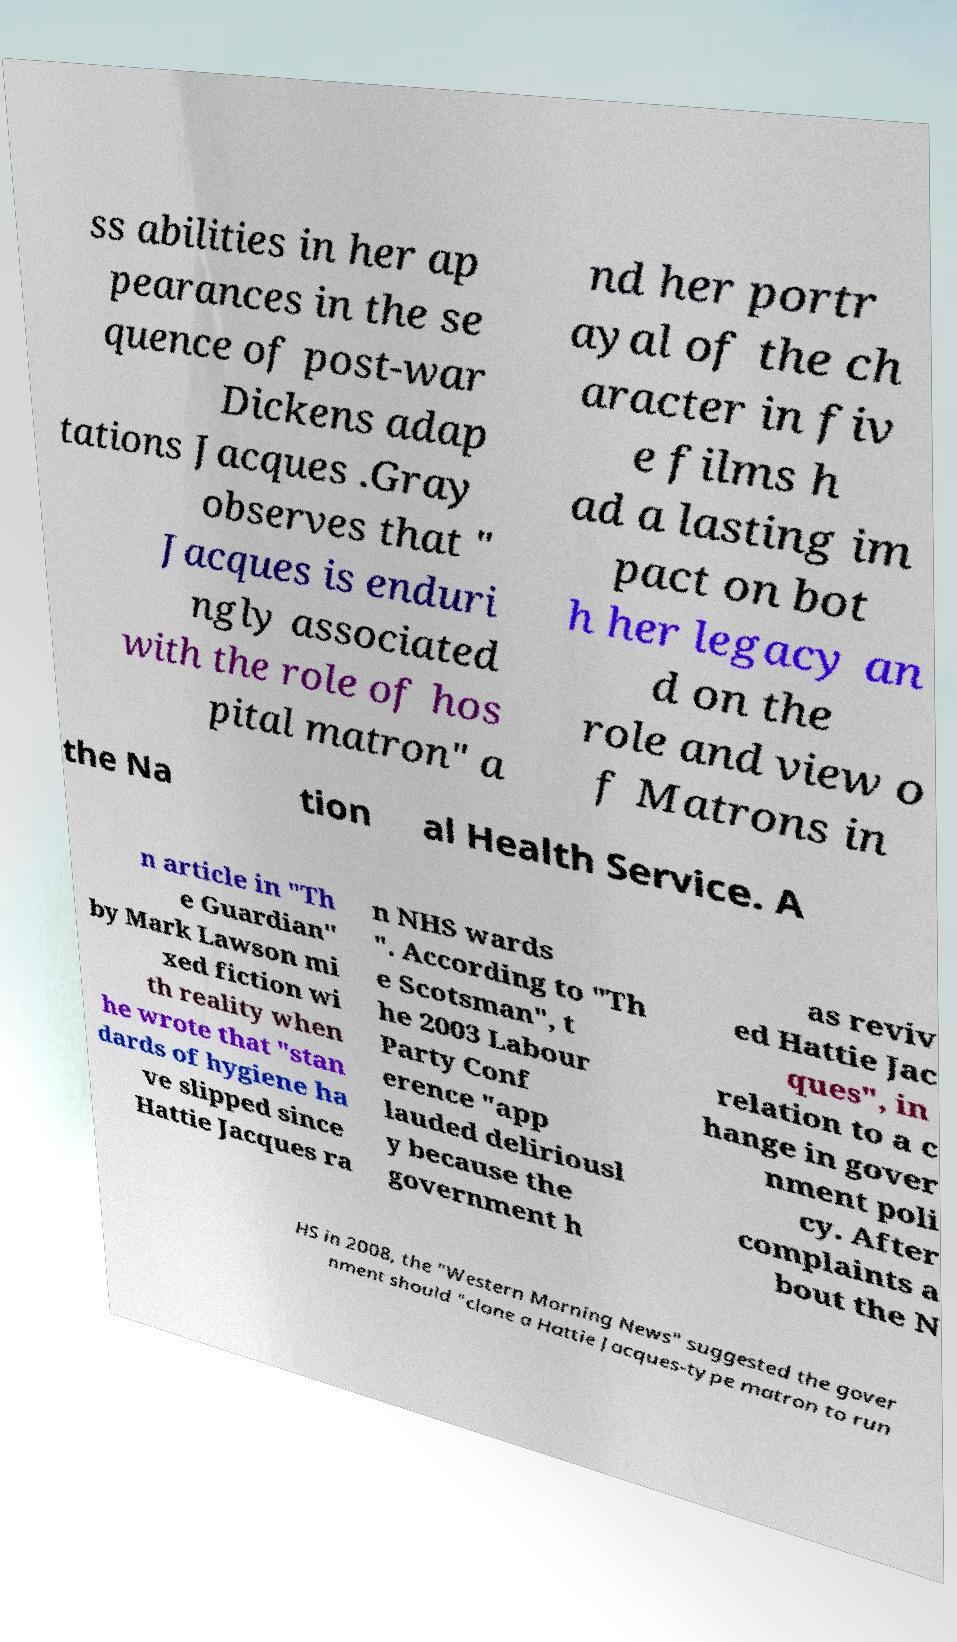Can you read and provide the text displayed in the image?This photo seems to have some interesting text. Can you extract and type it out for me? ss abilities in her ap pearances in the se quence of post-war Dickens adap tations Jacques .Gray observes that " Jacques is enduri ngly associated with the role of hos pital matron" a nd her portr ayal of the ch aracter in fiv e films h ad a lasting im pact on bot h her legacy an d on the role and view o f Matrons in the Na tion al Health Service. A n article in "Th e Guardian" by Mark Lawson mi xed fiction wi th reality when he wrote that "stan dards of hygiene ha ve slipped since Hattie Jacques ra n NHS wards ". According to "Th e Scotsman", t he 2003 Labour Party Conf erence "app lauded deliriousl y because the government h as reviv ed Hattie Jac ques", in relation to a c hange in gover nment poli cy. After complaints a bout the N HS in 2008, the "Western Morning News" suggested the gover nment should "clone a Hattie Jacques-type matron to run 